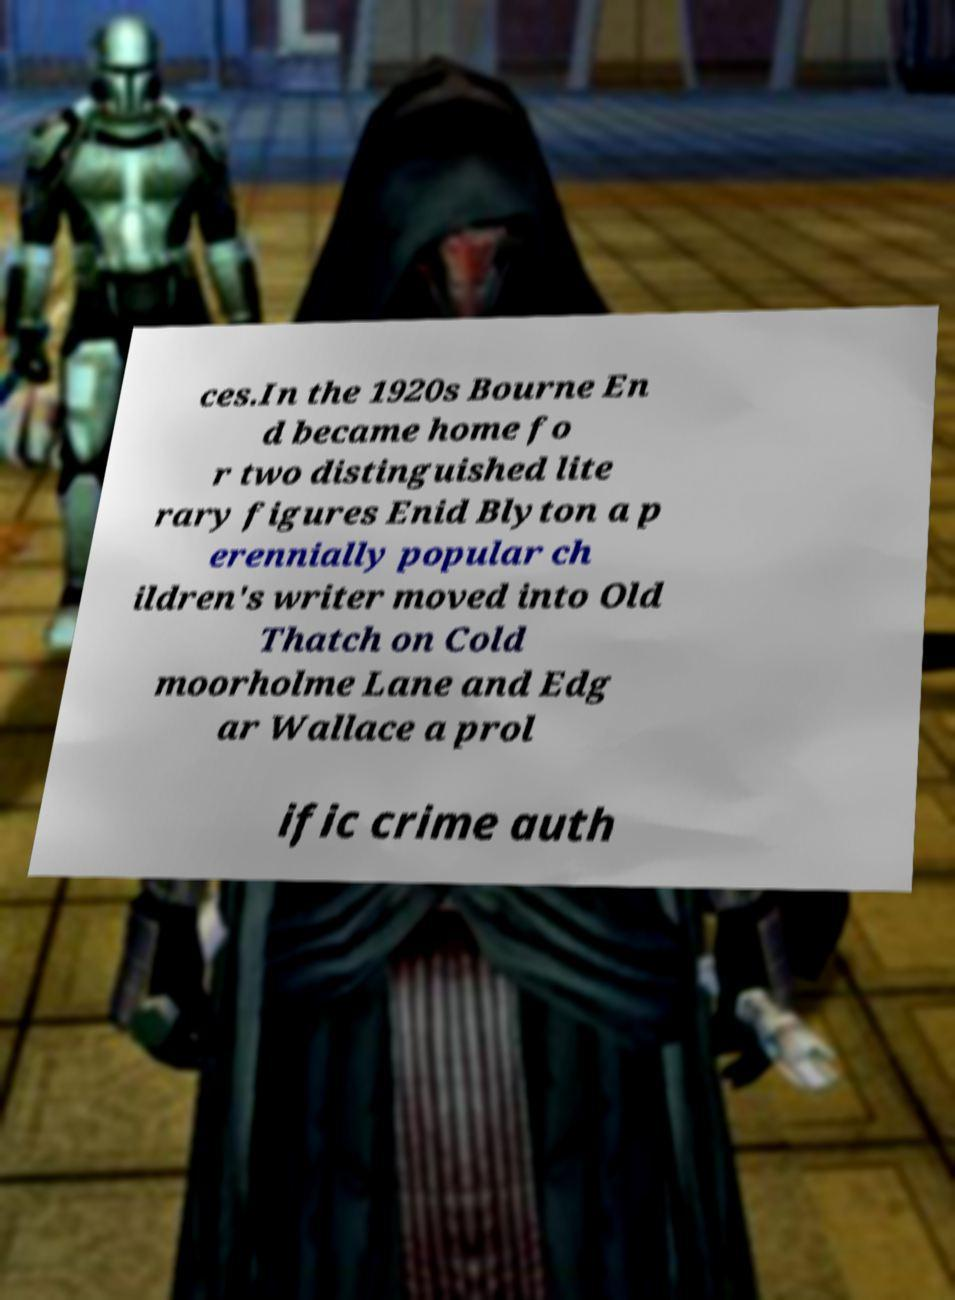Can you read and provide the text displayed in the image?This photo seems to have some interesting text. Can you extract and type it out for me? ces.In the 1920s Bourne En d became home fo r two distinguished lite rary figures Enid Blyton a p erennially popular ch ildren's writer moved into Old Thatch on Cold moorholme Lane and Edg ar Wallace a prol ific crime auth 